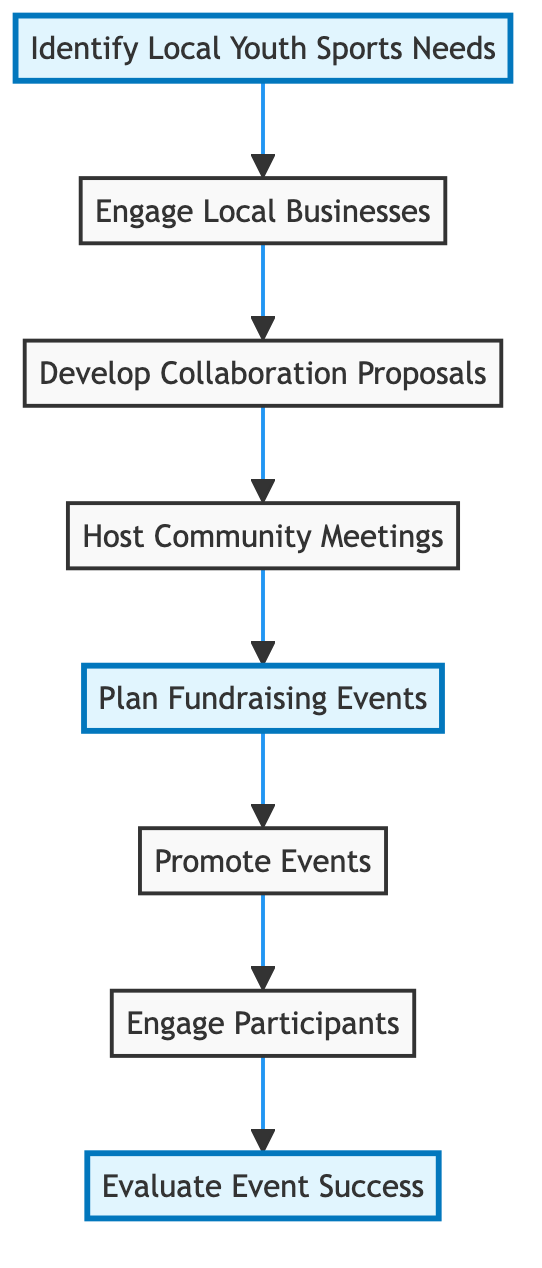What is the first step in the flow chart? The flow chart begins with the node "Identify Local Youth Sports Needs," which is the starting point of the entire process according to the layout.
Answer: Identify Local Youth Sports Needs How many main steps are there in the process? Counting all the distinct nodes in the flow chart, there are a total of eight main steps from "Identify Local Youth Sports Needs" to "Evaluate Event Success."
Answer: 8 What nodes lead to "Plan Fundraising Events"? The node "Host Community Meetings" directly connects to "Plan Fundraising Events," indicating it's the preceding step immediately before planning these events.
Answer: Host Community Meetings Which step involves advertising events? The diagram indicates that "Promote Events" is the dedicated step where the focus is on utilizing different media to advertise the events.
Answer: Promote Events What is a direct result of "Engage Participants"? Following the flow from "Engage Participants," the next step is "Evaluate Event Success," showcasing that participant engagement leads directly to assessing how successful the events have been.
Answer: Evaluate Event Success What is the purpose of "Develop Collaboration Proposals"? This step outlines the benefits of sponsorship for local businesses, providing a clear goal of creating supportive collaborations for the sporting events.
Answer: Outline benefits of sponsorship Which nodes are highlighted in the diagram? The highlighted nodes are "Identify Local Youth Sports Needs," "Plan Fundraising Events," and "Evaluate Event Success," emphasizing their importance in the community engagement strategy.
Answer: Identify Local Youth Sports Needs, Plan Fundraising Events, Evaluate Event Success What is the final step in the flow chart? The last node in the flow chart, which represents the final action in the community engagement strategy, is "Evaluate Event Success."
Answer: Evaluate Event Success 